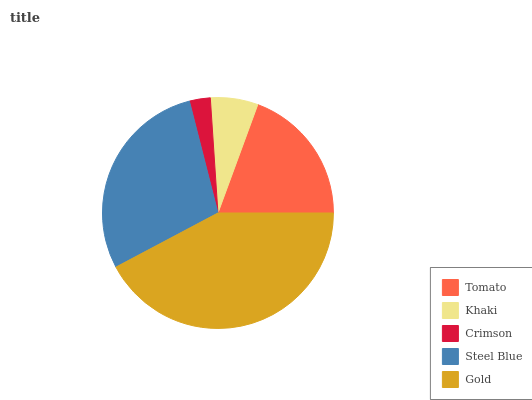Is Crimson the minimum?
Answer yes or no. Yes. Is Gold the maximum?
Answer yes or no. Yes. Is Khaki the minimum?
Answer yes or no. No. Is Khaki the maximum?
Answer yes or no. No. Is Tomato greater than Khaki?
Answer yes or no. Yes. Is Khaki less than Tomato?
Answer yes or no. Yes. Is Khaki greater than Tomato?
Answer yes or no. No. Is Tomato less than Khaki?
Answer yes or no. No. Is Tomato the high median?
Answer yes or no. Yes. Is Tomato the low median?
Answer yes or no. Yes. Is Steel Blue the high median?
Answer yes or no. No. Is Steel Blue the low median?
Answer yes or no. No. 